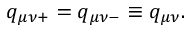<formula> <loc_0><loc_0><loc_500><loc_500>q _ { \mu \nu + } = q _ { \mu \nu - } \equiv q _ { \mu \nu } .</formula> 